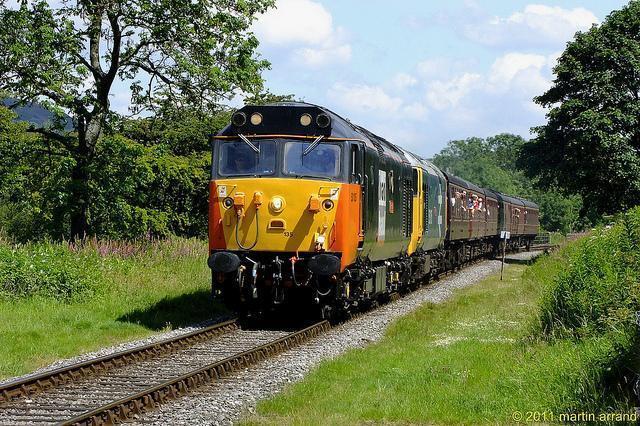How many tracks on the ground?
Give a very brief answer. 2. How many orange signs are there?
Give a very brief answer. 0. 